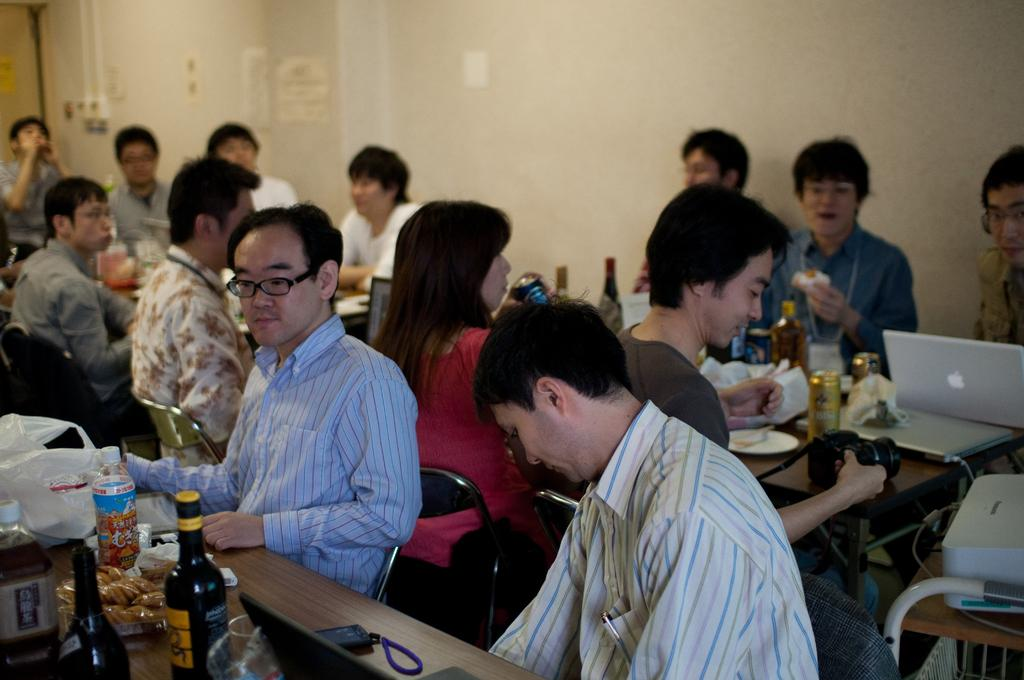What are the people in the image doing? The people in the image are sitting on chairs near tables. What can be seen on the tables? There are objects placed on the tables. What is on the wall in the image? There are posters on the wall. What invention is being demonstrated in the image? There is no invention being demonstrated in the image; it simply shows people sitting near tables with objects and posters. What type of sport is being played in the image? There is no sport being played in the image; it only shows people sitting near tables with objects and posters. 